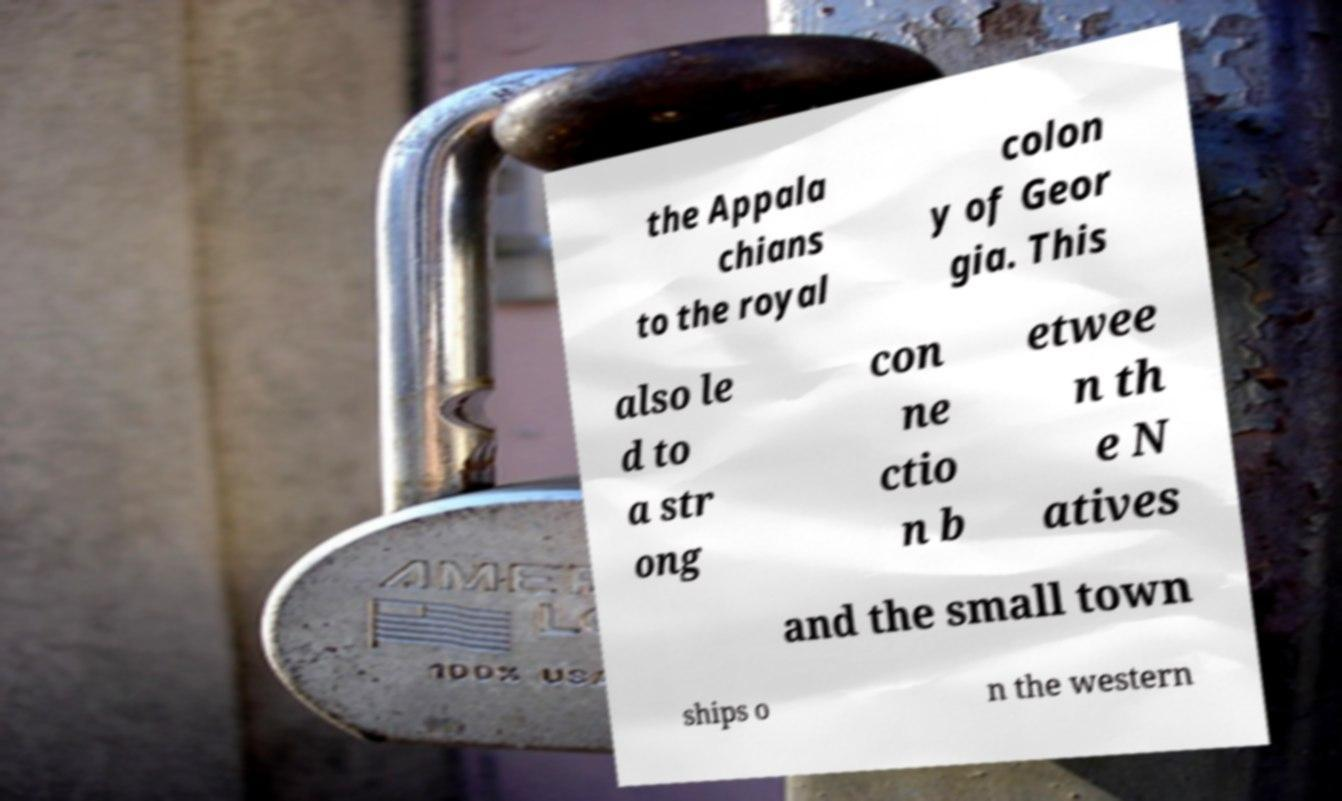Could you extract and type out the text from this image? the Appala chians to the royal colon y of Geor gia. This also le d to a str ong con ne ctio n b etwee n th e N atives and the small town ships o n the western 